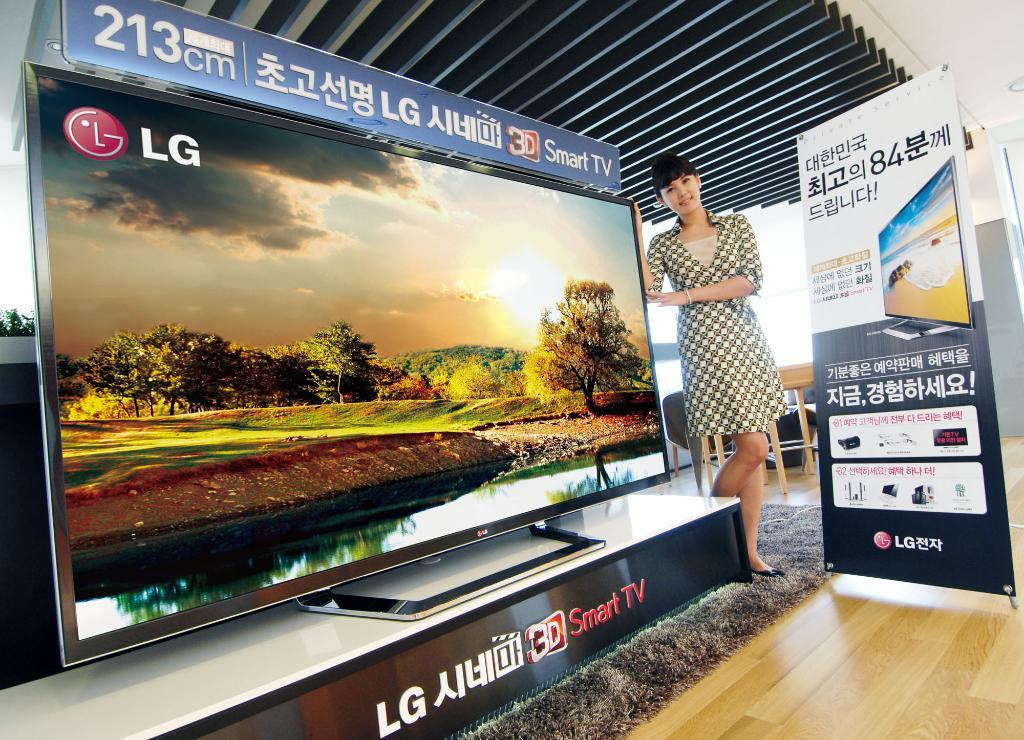<image>
Render a clear and concise summary of the photo. A woman stands next to a huge LG Smart TV. 